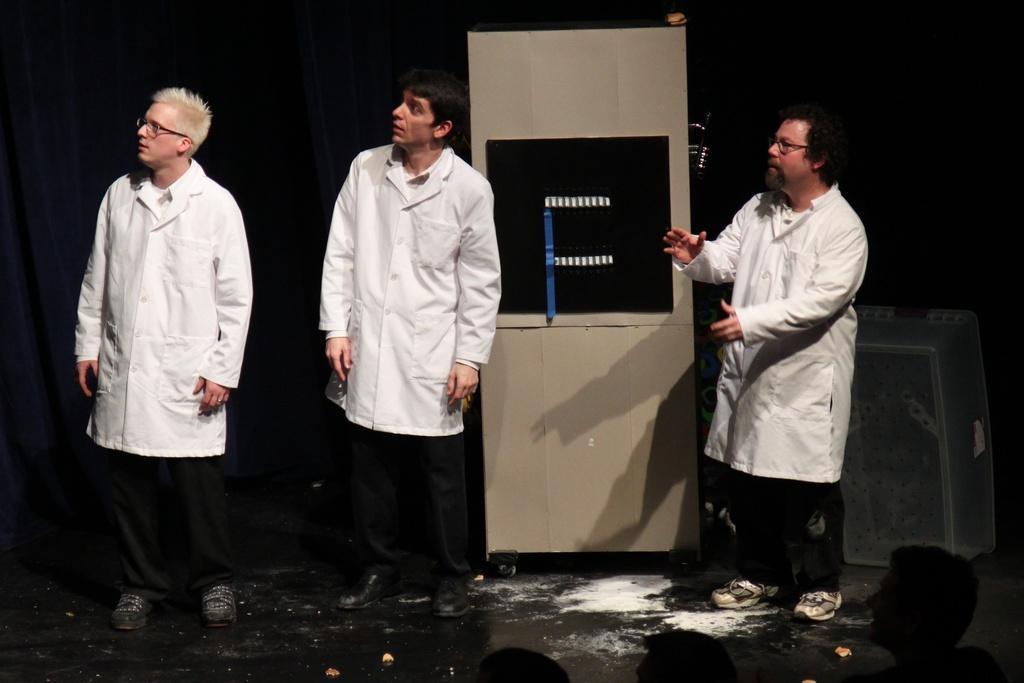Can you describe this image briefly? In the image there are three men and behind them there is some object. 